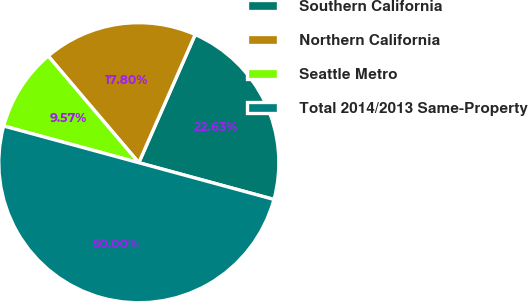Convert chart. <chart><loc_0><loc_0><loc_500><loc_500><pie_chart><fcel>Southern California<fcel>Northern California<fcel>Seattle Metro<fcel>Total 2014/2013 Same-Property<nl><fcel>22.63%<fcel>17.8%<fcel>9.57%<fcel>50.0%<nl></chart> 